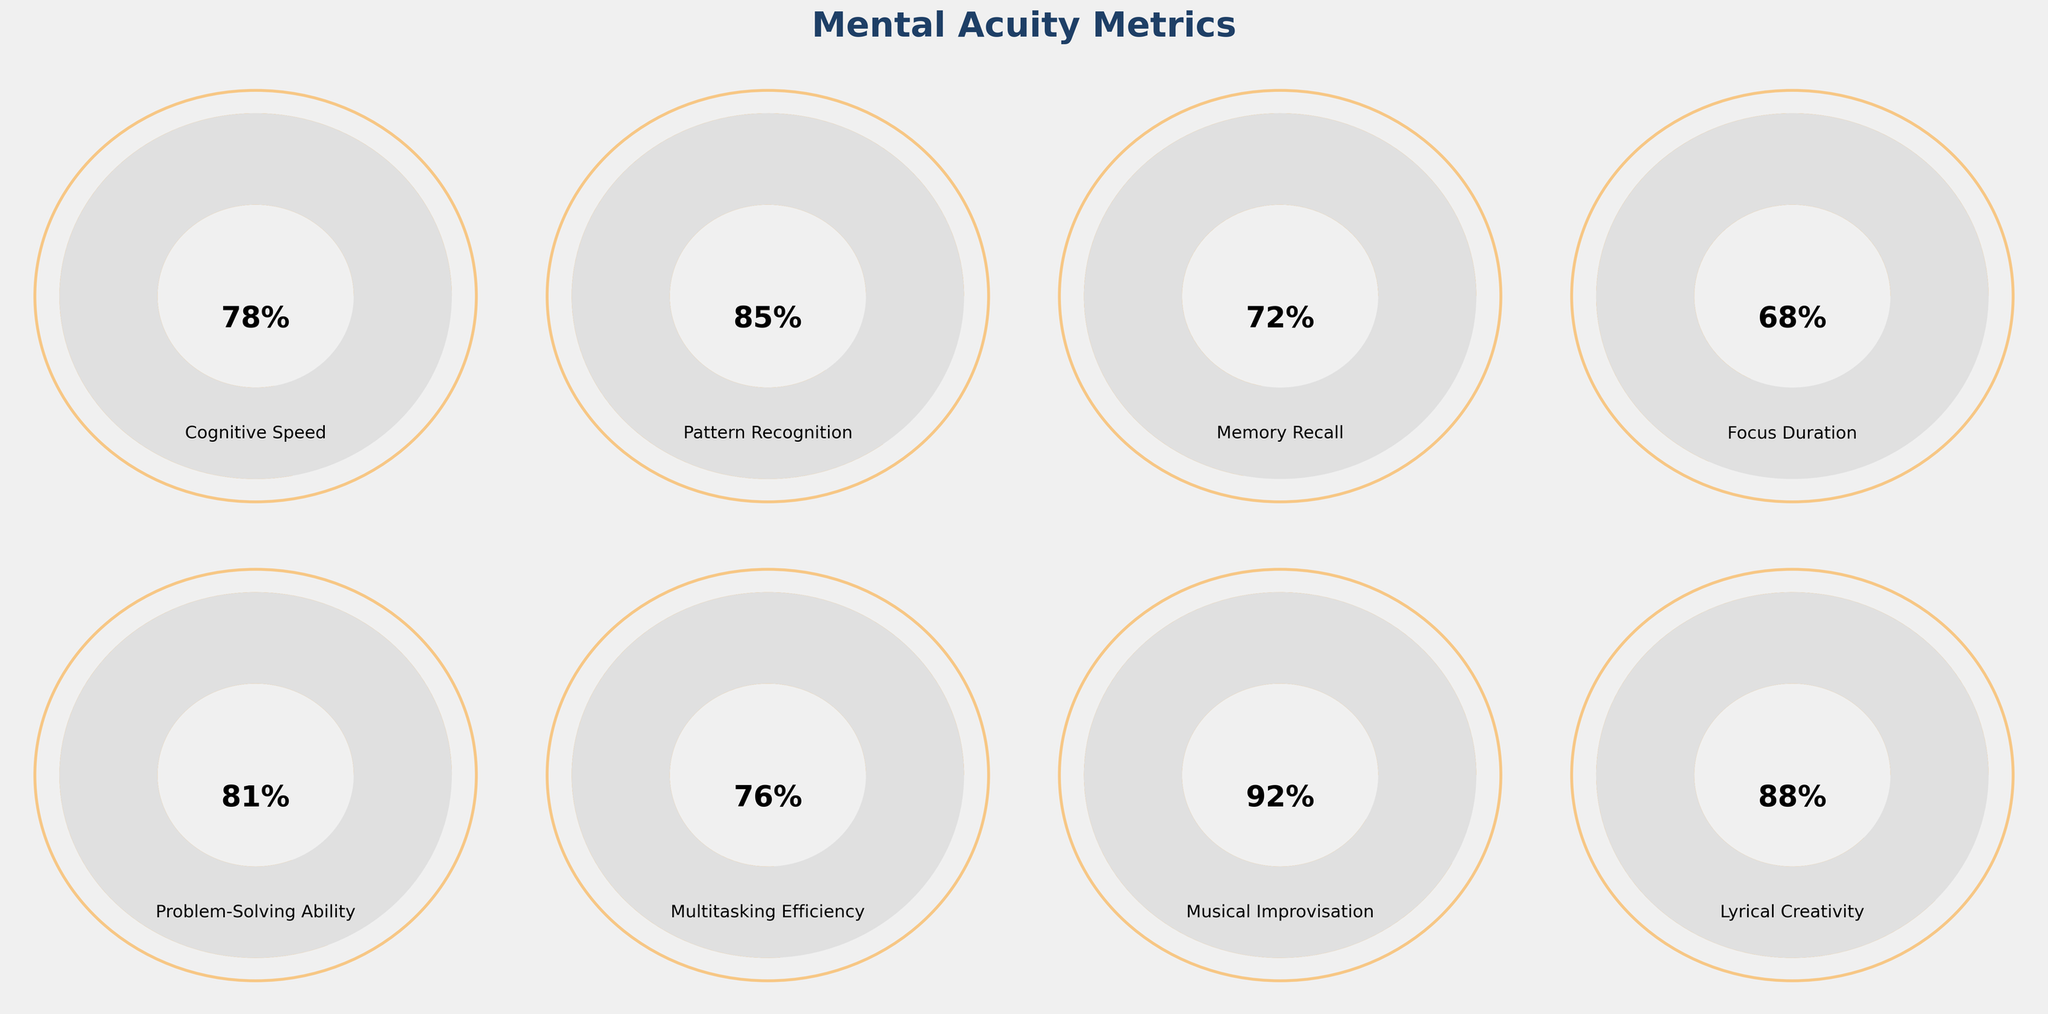Which mental acuity metric scored the highest? To find the highest score, look for the gauge chart with the value closest to 100%. Here, Musical Improvisation scored 92%, which is the highest among all metrics.
Answer: Musical Improvisation What is the title of the figure? The title is prominently displayed at the top of the figure. It reads "Mental Acuity Metrics".
Answer: Mental Acuity Metrics How many metrics are represented in the figure? By counting the individual gauge charts, you can determine there are eight different metrics shown.
Answer: Eight Which metric has the lowest score? To determine the lowest score, identify the gauge chart with the smallest percentage. Focus Duration, with a score of 68%, is the lowest among the metrics.
Answer: Focus Duration What is the difference in percentage between Memory Recall and Pattern Recognition? Memory Recall scores 72%, and Pattern Recognition scores 85%. The difference is calculated as 85% - 72% = 13%.
Answer: 13% How many metrics scored above 80%? To find how many metrics scored above 80%, count the individual gauges with a value beyond this threshold. The metrics are Pattern Recognition (85%), Problem-Solving Ability (81%), Musical Improvisation (92%), and Lyrical Creativity (88%), totaling four.
Answer: Four Which metric scored just below Multitasking Efficiency? Multitasking Efficiency scored 76%. The metric with the closest but lower score is Memory Recall at 72%.
Answer: Memory Recall What is the average score of all the metrics? Sum the scores of all eight metrics and divide by the number of metrics. The total score is 78 + 85 + 72 + 68 + 81 + 76 + 92 + 88 = 640. The average is 640 / 8 = 80%.
Answer: 80% Are there any metrics with equal scores? Visually inspect for any gauge charts with the same percentage score. In this case, there are no metrics with equal scores.
Answer: No What is the combined score of Cognitive Speed and Focus Duration? Add the scores of Cognitive Speed (78%) and Focus Duration (68%) to get their combined total. 78 + 68 = 146.
Answer: 146 